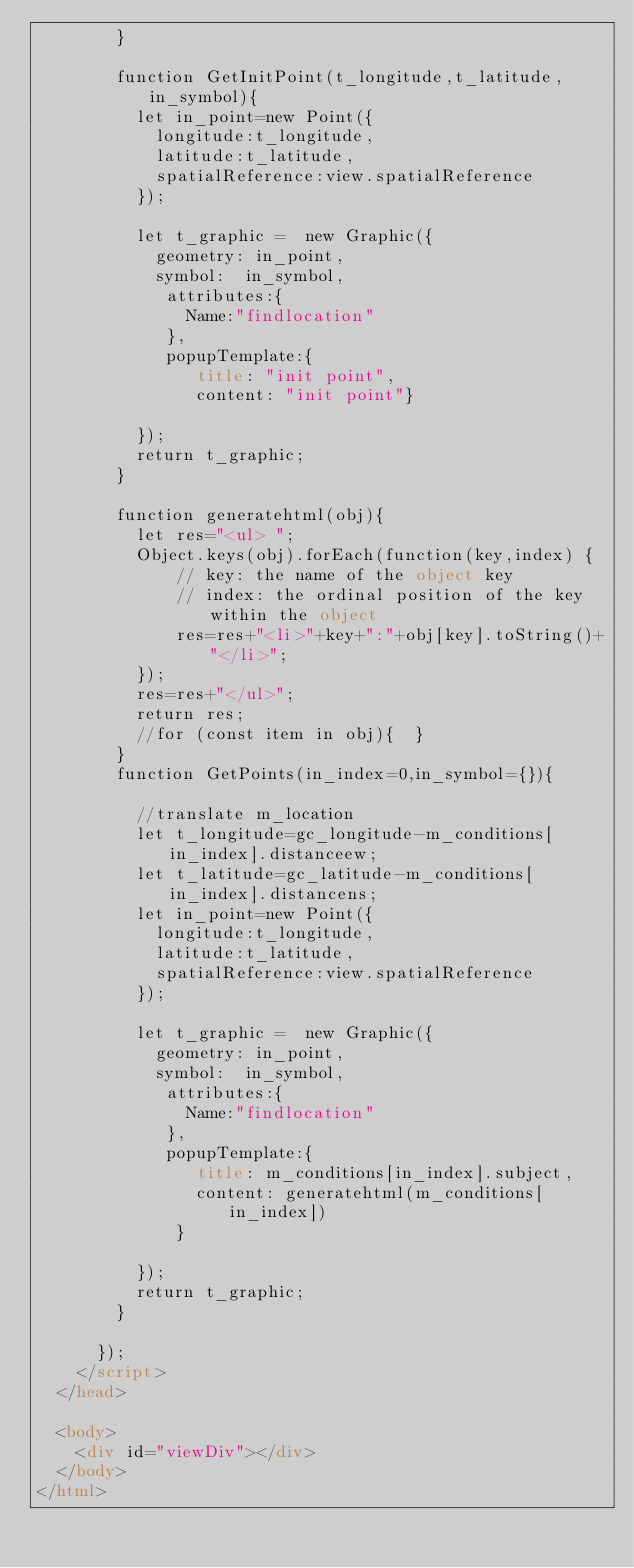<code> <loc_0><loc_0><loc_500><loc_500><_HTML_>        }

        function GetInitPoint(t_longitude,t_latitude,in_symbol){
          let in_point=new Point({
            longitude:t_longitude,
            latitude:t_latitude,
            spatialReference:view.spatialReference
          });

          let t_graphic =  new Graphic({
            geometry: in_point,
            symbol:  in_symbol,
             attributes:{
               Name:"findlocation"
             },
             popupTemplate:{
                title: "init point",
                content: "init point"}

          });
          return t_graphic;
        }

        function generatehtml(obj){
          let res="<ul> ";
          Object.keys(obj).forEach(function(key,index) {
              // key: the name of the object key
              // index: the ordinal position of the key within the object
              res=res+"<li>"+key+":"+obj[key].toString()+"</li>";
          });
          res=res+"</ul>";
          return res;
          //for (const item in obj){  }
        }
        function GetPoints(in_index=0,in_symbol={}){

          //translate m_location
          let t_longitude=gc_longitude-m_conditions[in_index].distanceew;
          let t_latitude=gc_latitude-m_conditions[in_index].distancens;
          let in_point=new Point({
            longitude:t_longitude,
            latitude:t_latitude,
            spatialReference:view.spatialReference
          });

          let t_graphic =  new Graphic({
            geometry: in_point,
            symbol:  in_symbol,
             attributes:{
               Name:"findlocation"
             },
             popupTemplate:{
                title: m_conditions[in_index].subject,
                content: generatehtml(m_conditions[in_index])
              }

          });
          return t_graphic;
        }

      });
    </script>
  </head>

  <body>
    <div id="viewDiv"></div>
  </body>
</html>
</code> 